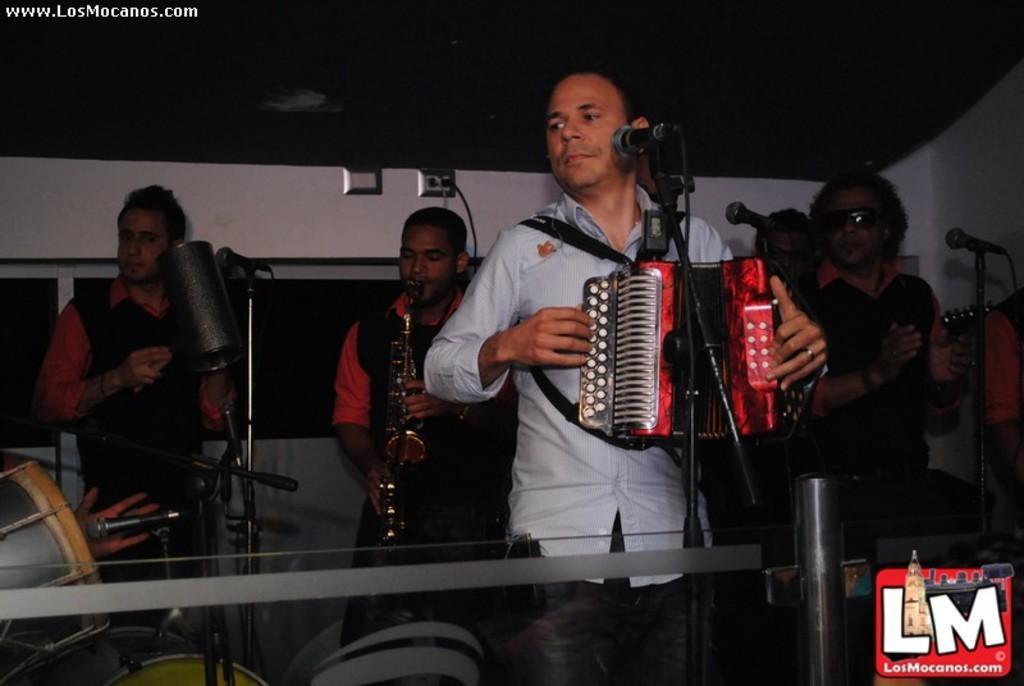How would you summarize this image in a sentence or two? In this image we can see the persons playing the musical instruments and standing in front of the mics with the stands. In the background, we can see the windows, wall and also the ceiling at the top. In the top left corner we can see the text and in the bottom right corner we can see the logo. 